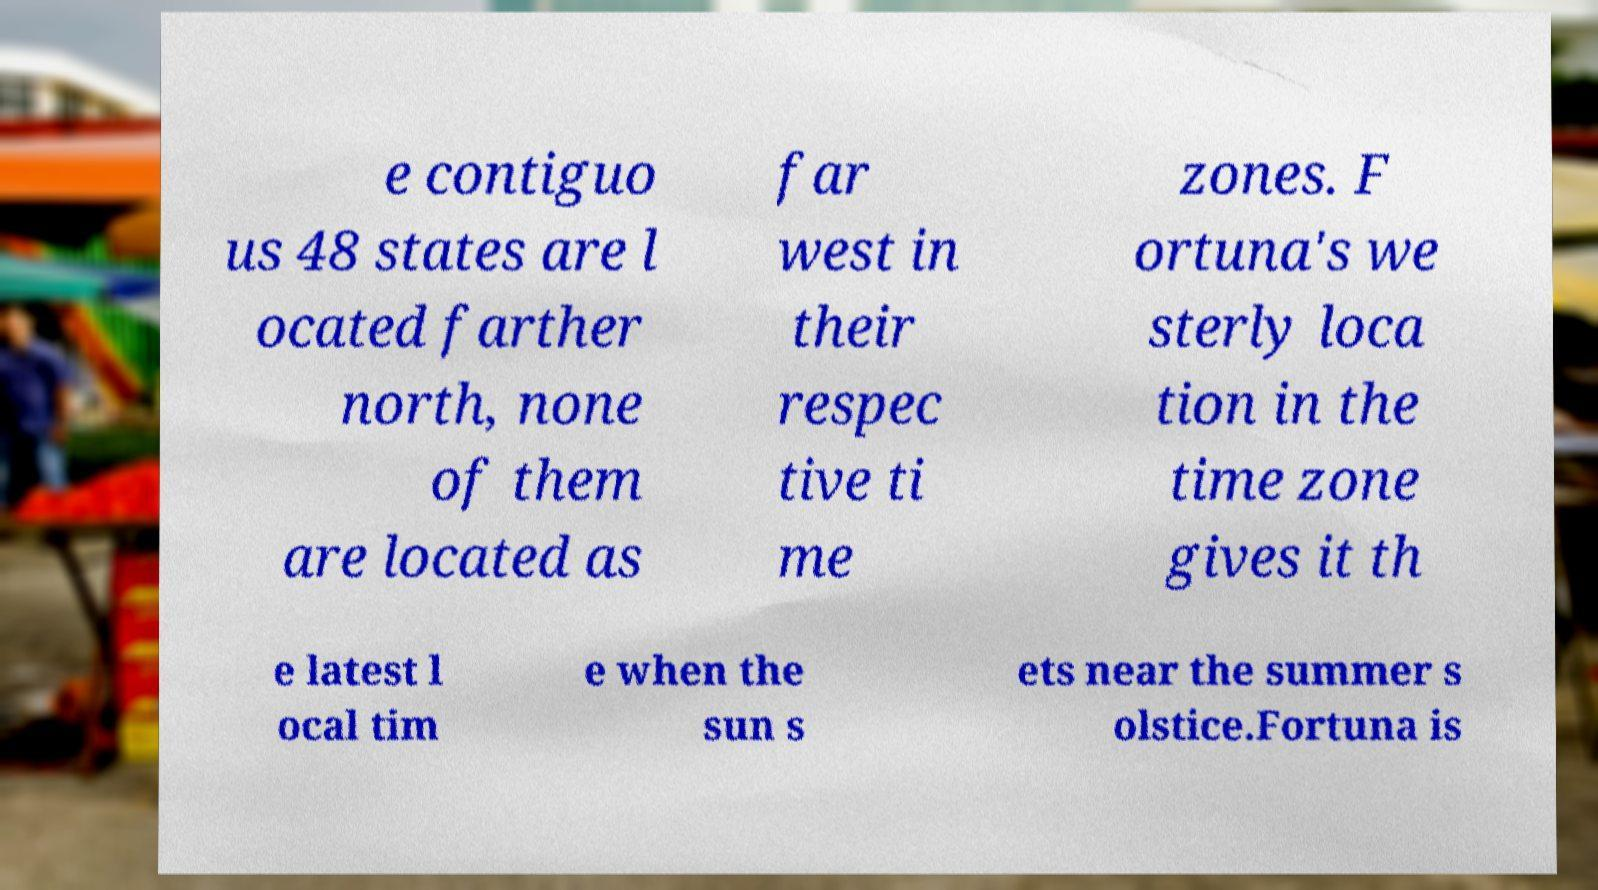Please identify and transcribe the text found in this image. e contiguo us 48 states are l ocated farther north, none of them are located as far west in their respec tive ti me zones. F ortuna's we sterly loca tion in the time zone gives it th e latest l ocal tim e when the sun s ets near the summer s olstice.Fortuna is 